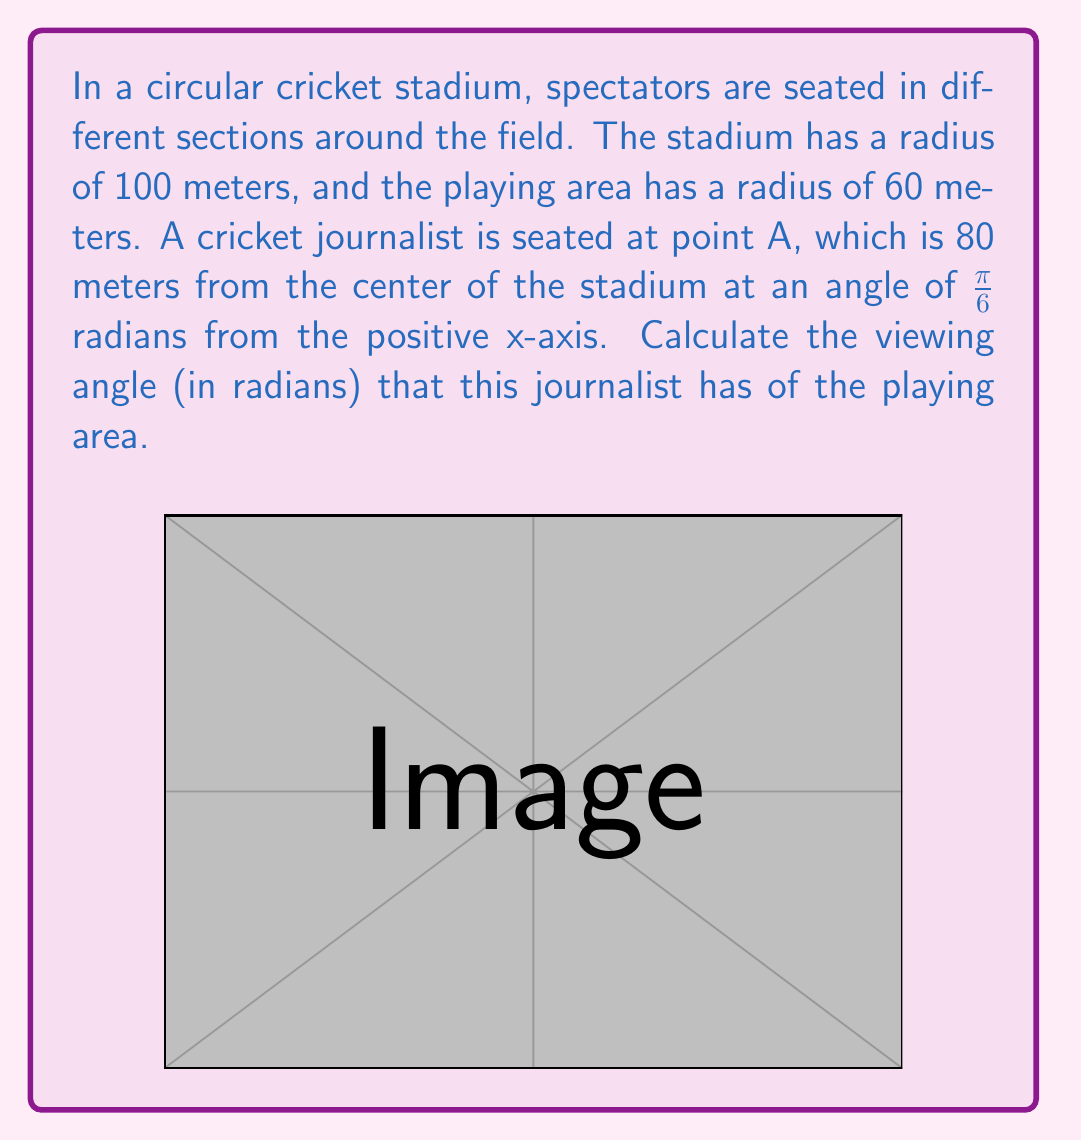Can you answer this question? Let's approach this step-by-step:

1) First, we need to understand what determines the viewing angle. It's the angle formed by the tangent lines from the spectator's position to the circle representing the playing area.

2) We can calculate this using the inverse sine function. The formula for the viewing angle $\theta$ is:

   $$\theta = 2 \arcsin(\frac{r}{d})$$

   where $r$ is the radius of the inner circle (playing area) and $d$ is the distance from the spectator to the center of the stadium.

3) We know that $r = 60$ meters.

4) To find $d$, we can use the given polar coordinates of the journalist's position. The journalist is at $(80, \frac{\pi}{6})$ in polar form. In this case, the radial coordinate directly gives us $d = 80$ meters.

5) Now we can plug these values into our formula:

   $$\theta = 2 \arcsin(\frac{60}{80})$$

6) Simplifying:
   $$\theta = 2 \arcsin(0.75)$$

7) Using a calculator or computer to evaluate this:
   $$\theta \approx 1.8479$$ radians

This angle represents the width of the playing area from the journalist's perspective.
Answer: The viewing angle is approximately 1.8479 radians. 